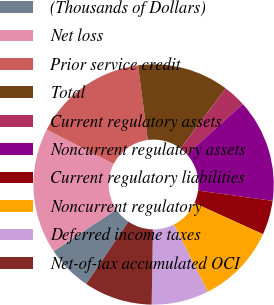<chart> <loc_0><loc_0><loc_500><loc_500><pie_chart><fcel>(Thousands of Dollars)<fcel>Net loss<fcel>Prior service credit<fcel>Total<fcel>Current regulatory assets<fcel>Noncurrent regulatory assets<fcel>Current regulatory liabilities<fcel>Noncurrent regulatory<fcel>Deferred income taxes<fcel>Net-of-tax accumulated OCI<nl><fcel>6.15%<fcel>16.92%<fcel>15.38%<fcel>12.31%<fcel>3.08%<fcel>13.85%<fcel>4.62%<fcel>10.77%<fcel>7.69%<fcel>9.23%<nl></chart> 